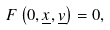<formula> <loc_0><loc_0><loc_500><loc_500>F \left ( 0 , \underline { x } , \underline { v } \right ) = 0 ,</formula> 